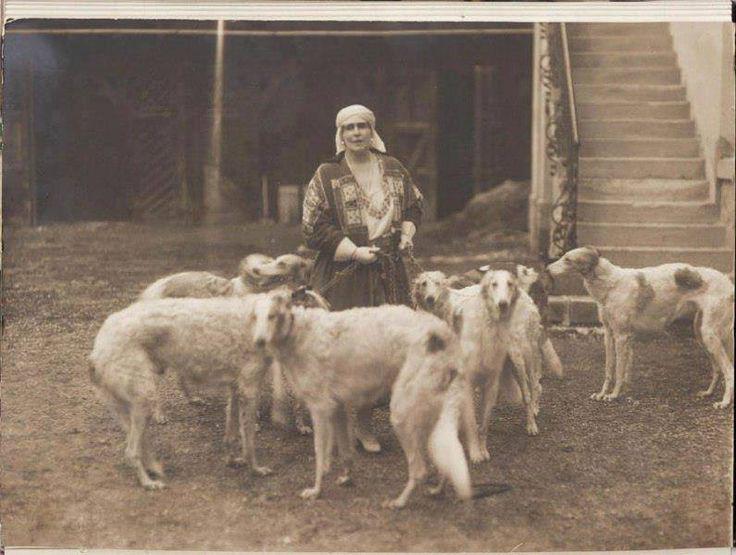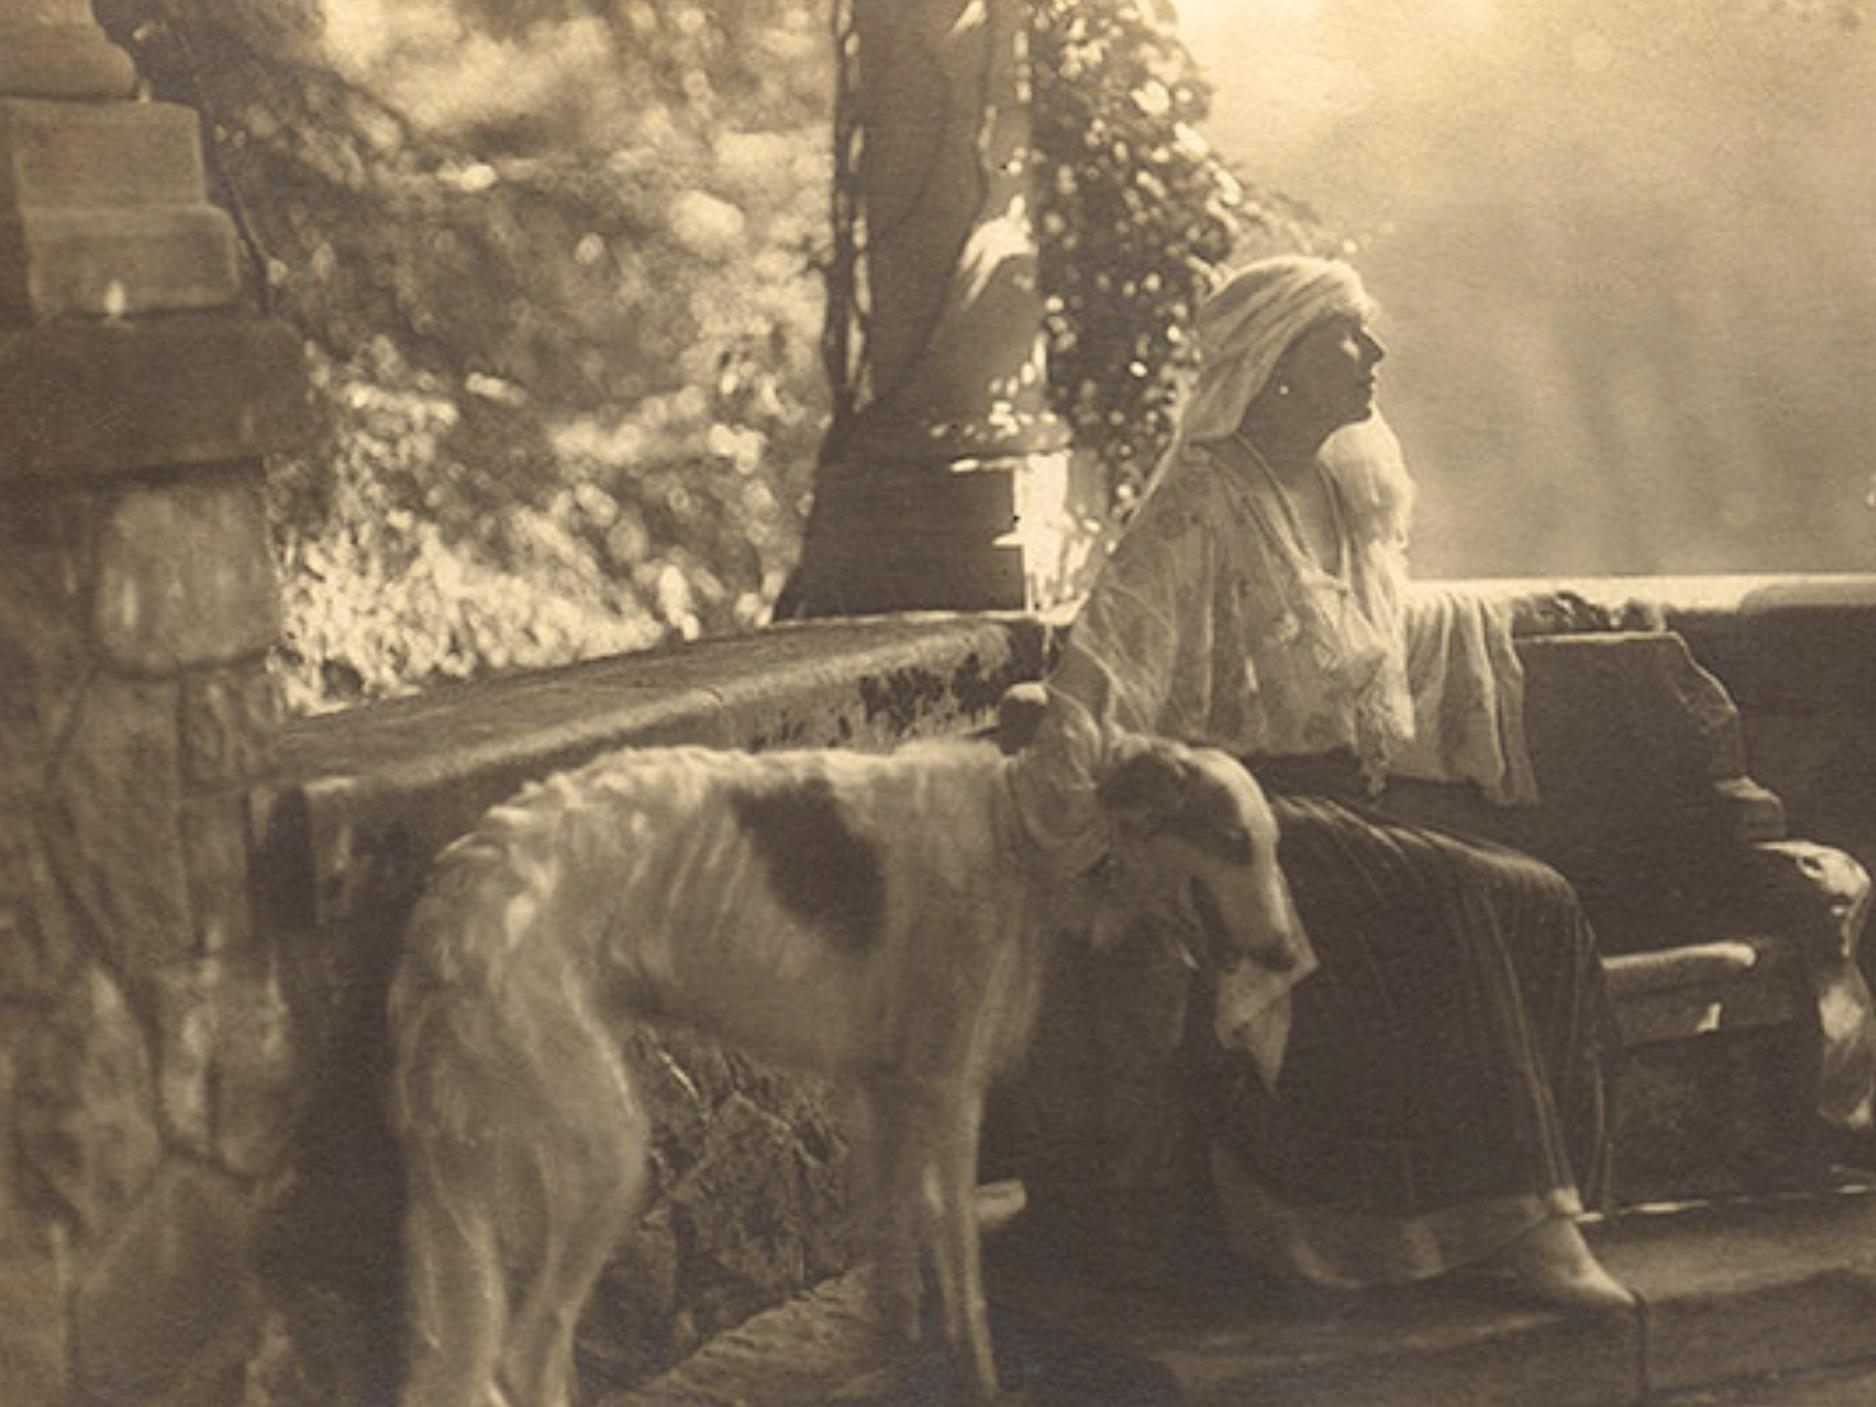The first image is the image on the left, the second image is the image on the right. Considering the images on both sides, is "The left image shows a woman in black standing behind one white hound." valid? Answer yes or no. No. 